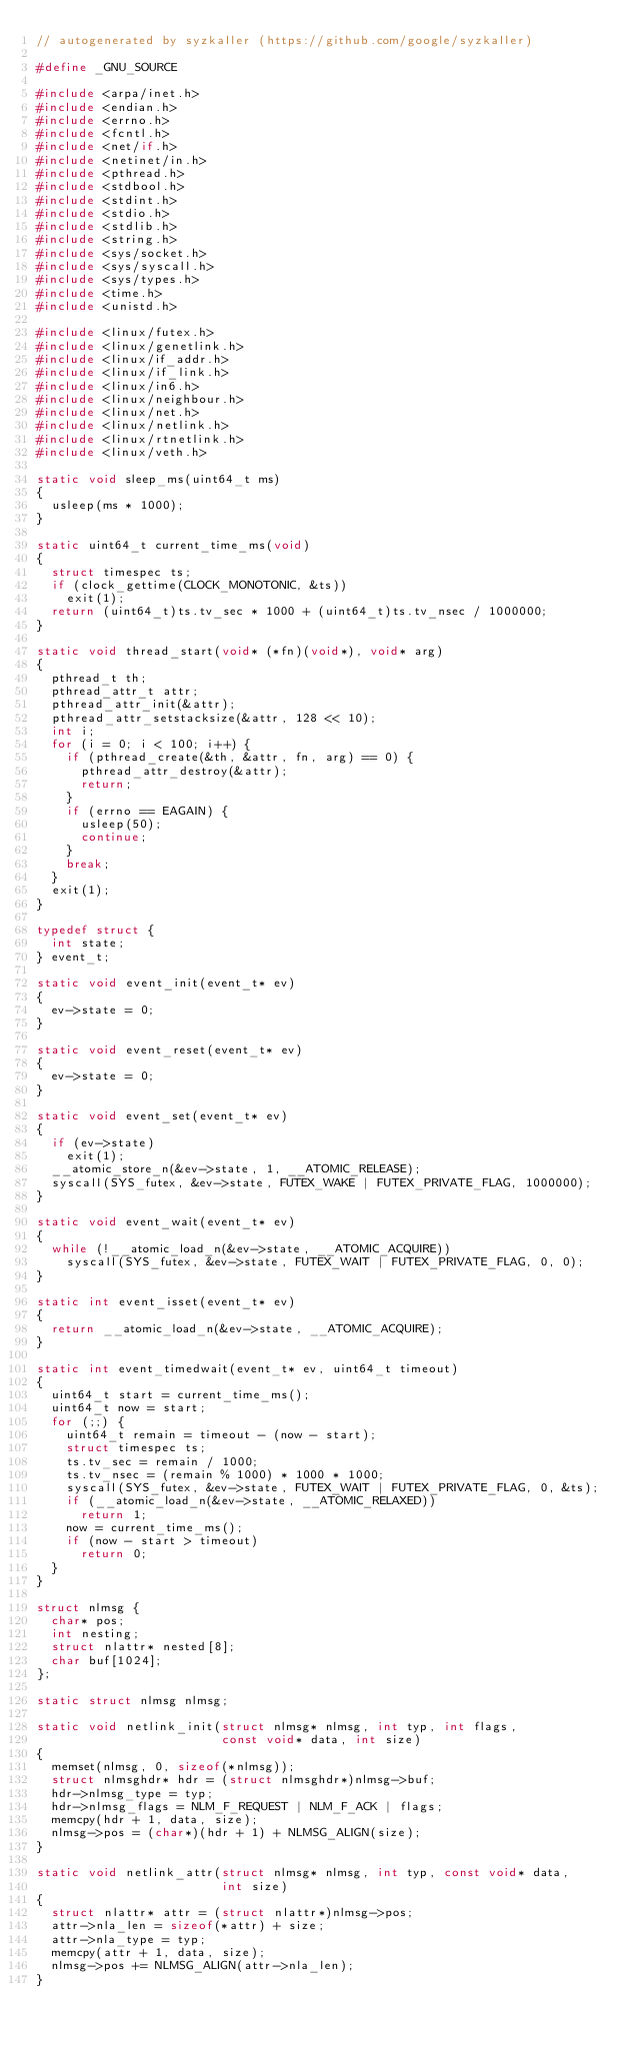Convert code to text. <code><loc_0><loc_0><loc_500><loc_500><_C_>// autogenerated by syzkaller (https://github.com/google/syzkaller)

#define _GNU_SOURCE

#include <arpa/inet.h>
#include <endian.h>
#include <errno.h>
#include <fcntl.h>
#include <net/if.h>
#include <netinet/in.h>
#include <pthread.h>
#include <stdbool.h>
#include <stdint.h>
#include <stdio.h>
#include <stdlib.h>
#include <string.h>
#include <sys/socket.h>
#include <sys/syscall.h>
#include <sys/types.h>
#include <time.h>
#include <unistd.h>

#include <linux/futex.h>
#include <linux/genetlink.h>
#include <linux/if_addr.h>
#include <linux/if_link.h>
#include <linux/in6.h>
#include <linux/neighbour.h>
#include <linux/net.h>
#include <linux/netlink.h>
#include <linux/rtnetlink.h>
#include <linux/veth.h>

static void sleep_ms(uint64_t ms)
{
  usleep(ms * 1000);
}

static uint64_t current_time_ms(void)
{
  struct timespec ts;
  if (clock_gettime(CLOCK_MONOTONIC, &ts))
    exit(1);
  return (uint64_t)ts.tv_sec * 1000 + (uint64_t)ts.tv_nsec / 1000000;
}

static void thread_start(void* (*fn)(void*), void* arg)
{
  pthread_t th;
  pthread_attr_t attr;
  pthread_attr_init(&attr);
  pthread_attr_setstacksize(&attr, 128 << 10);
  int i;
  for (i = 0; i < 100; i++) {
    if (pthread_create(&th, &attr, fn, arg) == 0) {
      pthread_attr_destroy(&attr);
      return;
    }
    if (errno == EAGAIN) {
      usleep(50);
      continue;
    }
    break;
  }
  exit(1);
}

typedef struct {
  int state;
} event_t;

static void event_init(event_t* ev)
{
  ev->state = 0;
}

static void event_reset(event_t* ev)
{
  ev->state = 0;
}

static void event_set(event_t* ev)
{
  if (ev->state)
    exit(1);
  __atomic_store_n(&ev->state, 1, __ATOMIC_RELEASE);
  syscall(SYS_futex, &ev->state, FUTEX_WAKE | FUTEX_PRIVATE_FLAG, 1000000);
}

static void event_wait(event_t* ev)
{
  while (!__atomic_load_n(&ev->state, __ATOMIC_ACQUIRE))
    syscall(SYS_futex, &ev->state, FUTEX_WAIT | FUTEX_PRIVATE_FLAG, 0, 0);
}

static int event_isset(event_t* ev)
{
  return __atomic_load_n(&ev->state, __ATOMIC_ACQUIRE);
}

static int event_timedwait(event_t* ev, uint64_t timeout)
{
  uint64_t start = current_time_ms();
  uint64_t now = start;
  for (;;) {
    uint64_t remain = timeout - (now - start);
    struct timespec ts;
    ts.tv_sec = remain / 1000;
    ts.tv_nsec = (remain % 1000) * 1000 * 1000;
    syscall(SYS_futex, &ev->state, FUTEX_WAIT | FUTEX_PRIVATE_FLAG, 0, &ts);
    if (__atomic_load_n(&ev->state, __ATOMIC_RELAXED))
      return 1;
    now = current_time_ms();
    if (now - start > timeout)
      return 0;
  }
}

struct nlmsg {
  char* pos;
  int nesting;
  struct nlattr* nested[8];
  char buf[1024];
};

static struct nlmsg nlmsg;

static void netlink_init(struct nlmsg* nlmsg, int typ, int flags,
                         const void* data, int size)
{
  memset(nlmsg, 0, sizeof(*nlmsg));
  struct nlmsghdr* hdr = (struct nlmsghdr*)nlmsg->buf;
  hdr->nlmsg_type = typ;
  hdr->nlmsg_flags = NLM_F_REQUEST | NLM_F_ACK | flags;
  memcpy(hdr + 1, data, size);
  nlmsg->pos = (char*)(hdr + 1) + NLMSG_ALIGN(size);
}

static void netlink_attr(struct nlmsg* nlmsg, int typ, const void* data,
                         int size)
{
  struct nlattr* attr = (struct nlattr*)nlmsg->pos;
  attr->nla_len = sizeof(*attr) + size;
  attr->nla_type = typ;
  memcpy(attr + 1, data, size);
  nlmsg->pos += NLMSG_ALIGN(attr->nla_len);
}
</code> 